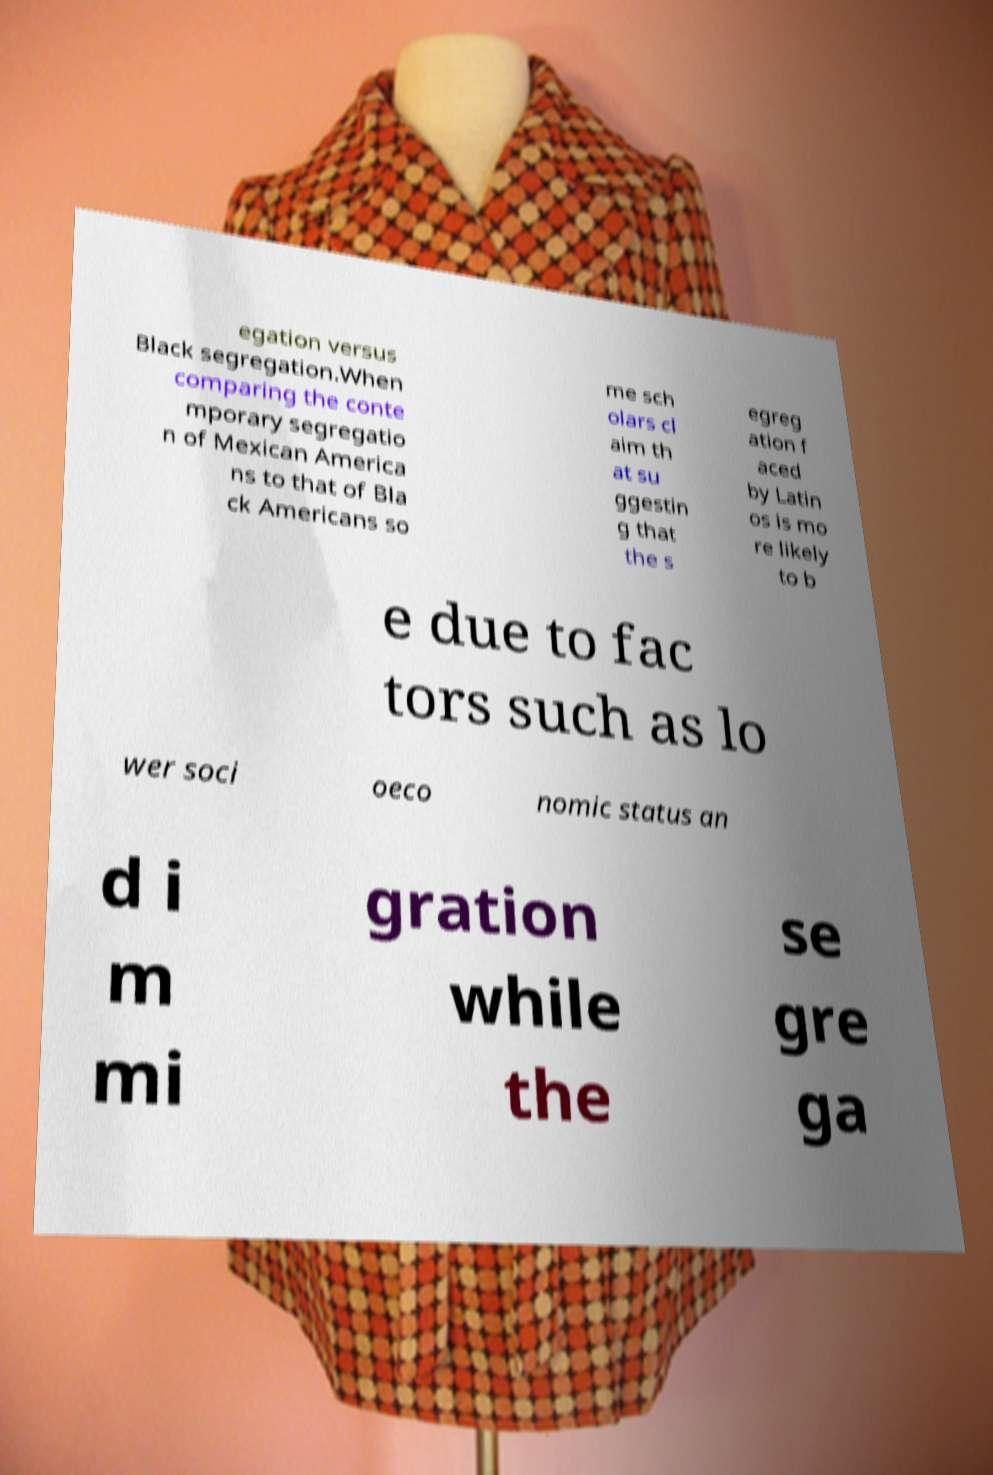Please identify and transcribe the text found in this image. egation versus Black segregation.When comparing the conte mporary segregatio n of Mexican America ns to that of Bla ck Americans so me sch olars cl aim th at su ggestin g that the s egreg ation f aced by Latin os is mo re likely to b e due to fac tors such as lo wer soci oeco nomic status an d i m mi gration while the se gre ga 